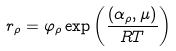Convert formula to latex. <formula><loc_0><loc_0><loc_500><loc_500>r _ { \rho } = \varphi _ { \rho } \exp \left ( \frac { ( \alpha _ { \rho } , { \mu } ) } { R T } \right )</formula> 